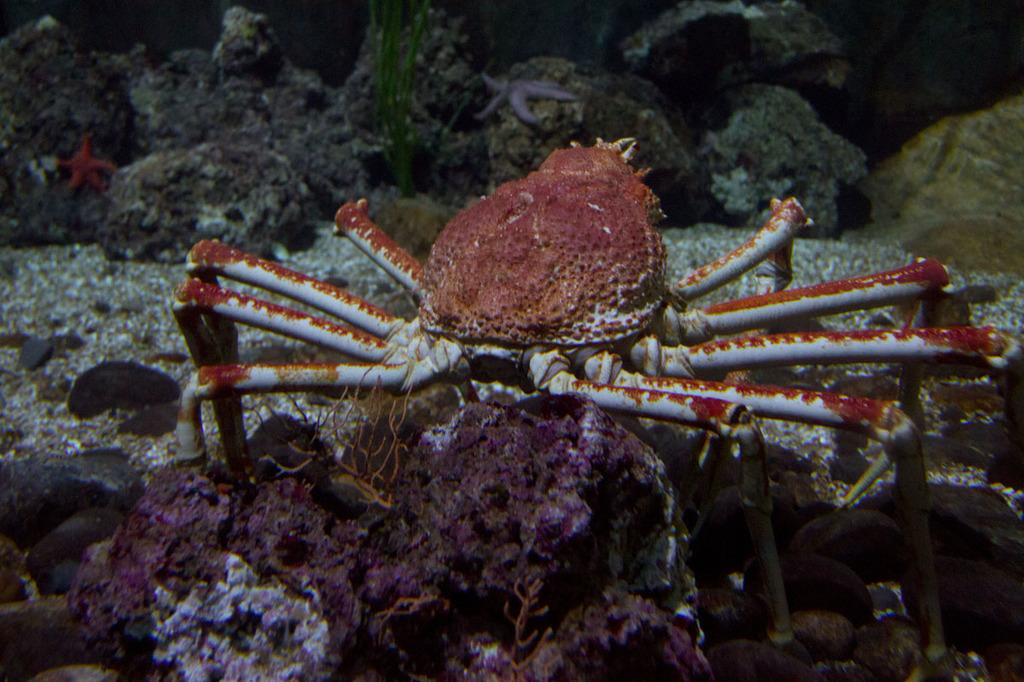What type of animal can be seen in the image? There is a water animal in the image. What type of surface is visible in the image? There is ground visible in the image. What marine creatures are present in the image? There are starfishes in the image. What type of vegetation is in the image? There is a plant in the image. What is the primary environment depicted in the image? There is water visible in the image. What type of paste is being used by the bat in the image? There is no bat or paste present in the image. How many grapes can be seen in the image? There are no grapes present in the image. 